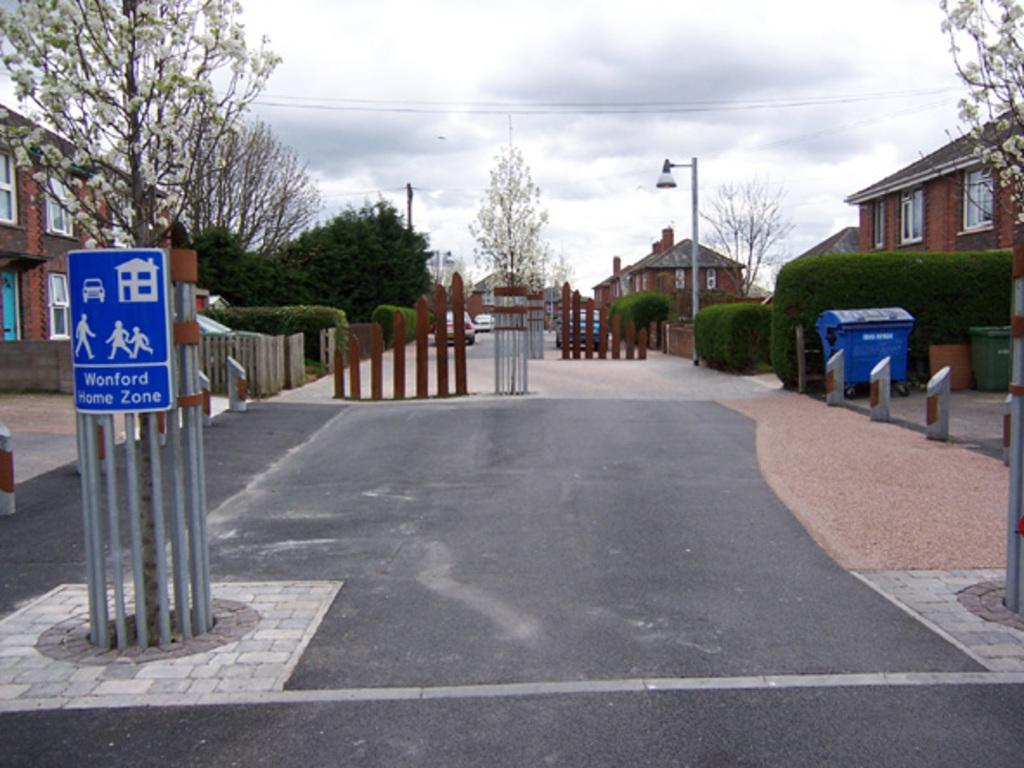<image>
Render a clear and concise summary of the photo. Red Brick Homes stand along a central walkway in the Wonford Home Zone. 